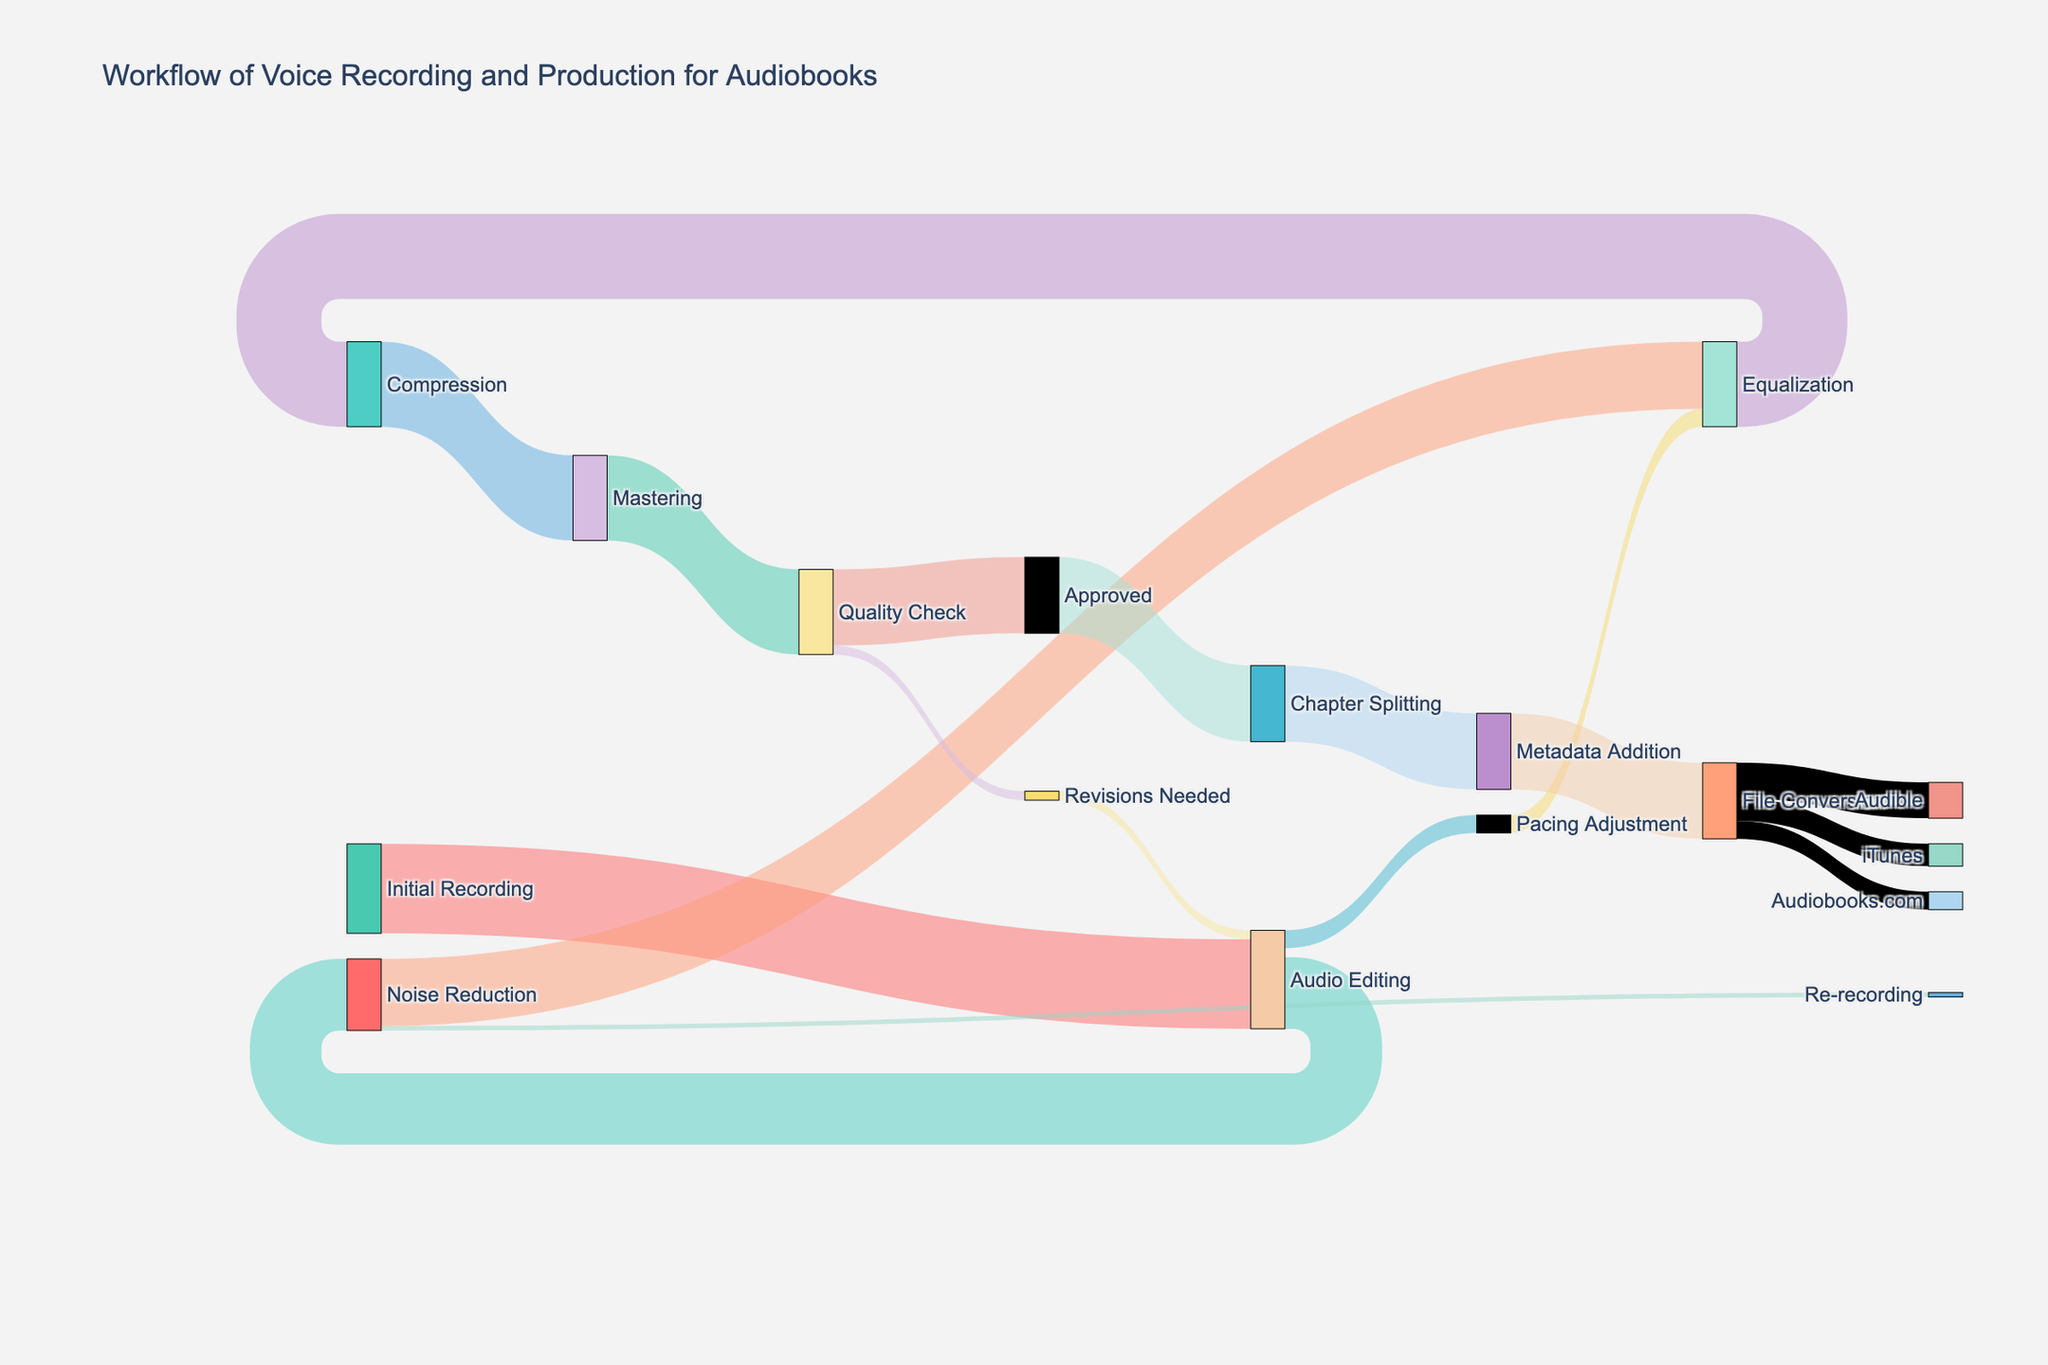What is the title of the figure? The title is located at the top of the figure in a bigger or bold font. It summarizes what the diagram is about. Look for a phrase that conveys the general topic of the visualization.
Answer: Workflow of Voice Recording and Production for Audiobooks Which stage has the highest initial value? Check the beginning stages of the Sankey diagram and identify the one with the highest value. Here, you should look for the thickest bar entering the first series of nodes.
Answer: Initial Recording What happens after Audio Editing? Trace the arrows starting from the "Audio Editing" node and see where they lead. Identify the subsequent stages connected to it by following the paths indicated by the arrows.
Answer: Noise Reduction, Pacing Adjustment How much audio undergoes Noise Reduction after Audio Editing? Identify the arrow linking "Audio Editing" to "Noise Reduction" and read its value to determine the amount processed.
Answer: 80 How many steps are there between Initial Recording and Mastering? Count each intermediate stage or node between "Initial Recording" and "Mastering". Make sure to include stages processing the audio sequentially.
Answer: 4 What percentage of the initial recording reaches the Quality Check stage? Compare the number flowing into the "Quality Check" node from the "Mastering" node to the initial recording value. Use the formula: (Value at Quality Check / Initial Recording Value) * 100.
Answer: 95% Where does the majority of the processed audio end up after file conversion? Follow the arrows departing from the "File Conversion" node and compare their values. Identify the target with the highest value.
Answer: Audible If some sections need revisions after the Quality Check, which stage do they return to? Trace the path starting from the "Quality Check" node labeled "Revisions Needed" and follow the arrow back to find the corresponding stage.
Answer: Audio Editing How many steps are involved from Equalization to iTunes distribution? Count each intermediate stage starting from the "Equalization" node all the way to the "iTunes" distribution node. Ensure no steps are missed.
Answer: 4 How much audio transitions from Equalization to Compression? Locate the arrow directing from "Equalization" to "Compression" and check its corresponding value.
Answer: 95 